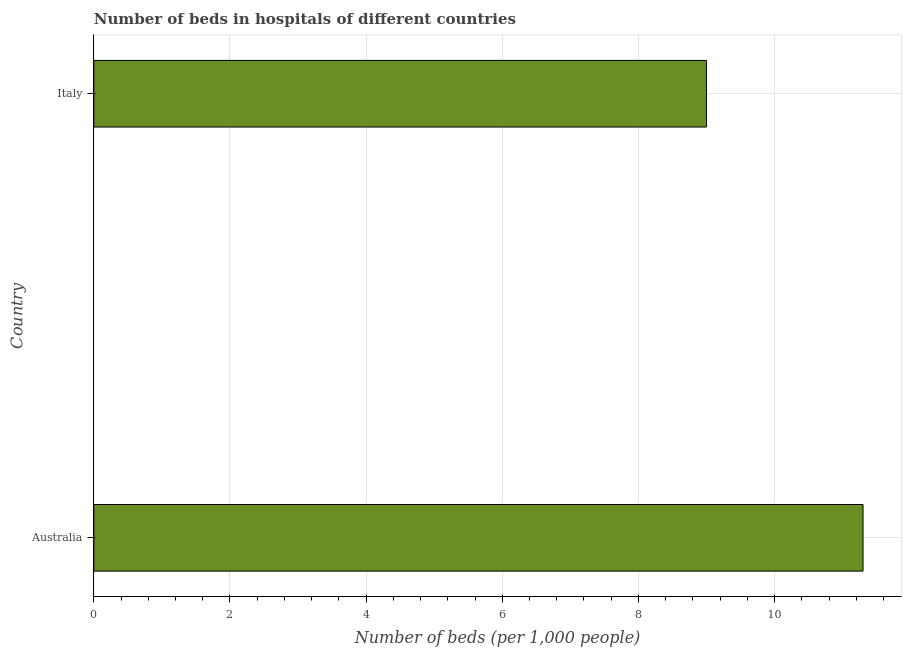Does the graph contain grids?
Your response must be concise. Yes. What is the title of the graph?
Offer a terse response. Number of beds in hospitals of different countries. What is the label or title of the X-axis?
Ensure brevity in your answer.  Number of beds (per 1,0 people). What is the label or title of the Y-axis?
Keep it short and to the point. Country. What is the number of hospital beds in Italy?
Provide a succinct answer. 9. Across all countries, what is the maximum number of hospital beds?
Provide a succinct answer. 11.3. Across all countries, what is the minimum number of hospital beds?
Provide a succinct answer. 9. What is the sum of the number of hospital beds?
Your response must be concise. 20.3. What is the difference between the number of hospital beds in Australia and Italy?
Offer a very short reply. 2.3. What is the average number of hospital beds per country?
Your answer should be compact. 10.15. What is the median number of hospital beds?
Keep it short and to the point. 10.15. In how many countries, is the number of hospital beds greater than 10.8 %?
Ensure brevity in your answer.  1. What is the ratio of the number of hospital beds in Australia to that in Italy?
Your response must be concise. 1.26. Is the number of hospital beds in Australia less than that in Italy?
Ensure brevity in your answer.  No. Are all the bars in the graph horizontal?
Your answer should be compact. Yes. How many countries are there in the graph?
Provide a short and direct response. 2. What is the difference between two consecutive major ticks on the X-axis?
Ensure brevity in your answer.  2. What is the Number of beds (per 1,000 people) of Australia?
Provide a succinct answer. 11.3. What is the difference between the Number of beds (per 1,000 people) in Australia and Italy?
Provide a succinct answer. 2.3. What is the ratio of the Number of beds (per 1,000 people) in Australia to that in Italy?
Give a very brief answer. 1.26. 